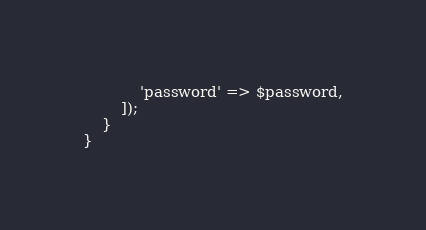Convert code to text. <code><loc_0><loc_0><loc_500><loc_500><_PHP_>            'password' => $password,
        ]);
    }
}
</code> 